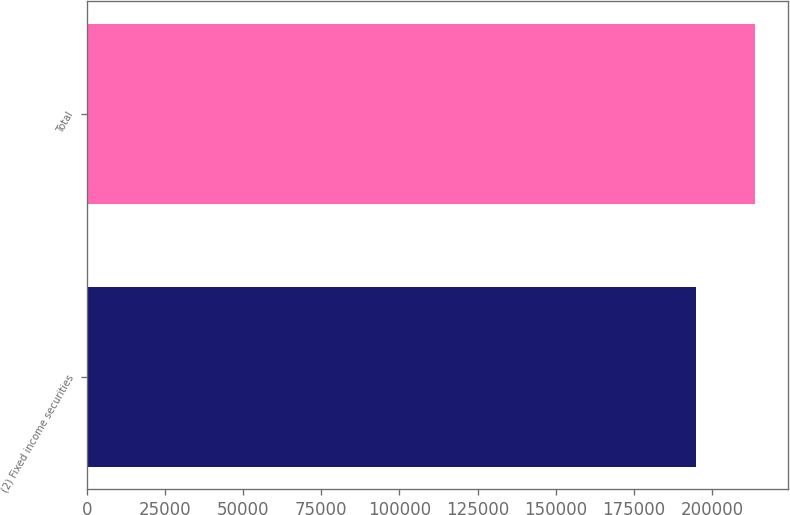<chart> <loc_0><loc_0><loc_500><loc_500><bar_chart><fcel>(2) Fixed income securities<fcel>Total<nl><fcel>194739<fcel>213689<nl></chart> 